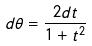Convert formula to latex. <formula><loc_0><loc_0><loc_500><loc_500>d \theta = \frac { 2 d t } { 1 + t ^ { 2 } }</formula> 